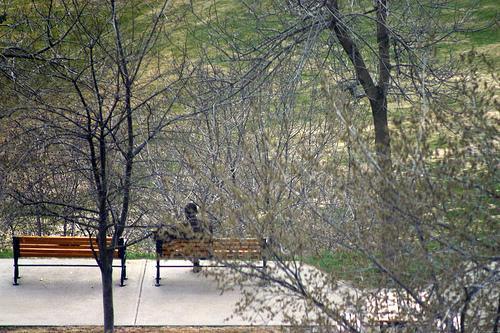How many benches are visible?
Give a very brief answer. 2. How many people are in the photo?
Give a very brief answer. 1. 